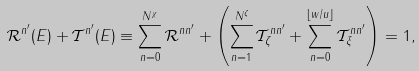<formula> <loc_0><loc_0><loc_500><loc_500>\mathcal { R } ^ { n ^ { \prime } } ( E ) + \mathcal { T } ^ { n ^ { \prime } } ( E ) \equiv \sum _ { n = 0 } ^ { N ^ { \chi } } \mathcal { R } ^ { n n ^ { \prime } } + \left ( \sum _ { n = 1 } ^ { N ^ { \zeta } } \mathcal { T } ^ { n n ^ { \prime } } _ { \zeta } + \sum _ { n = 0 } ^ { \lfloor w / u \rfloor } \mathcal { T } ^ { n n ^ { \prime } } _ { \xi } \right ) = 1 ,</formula> 